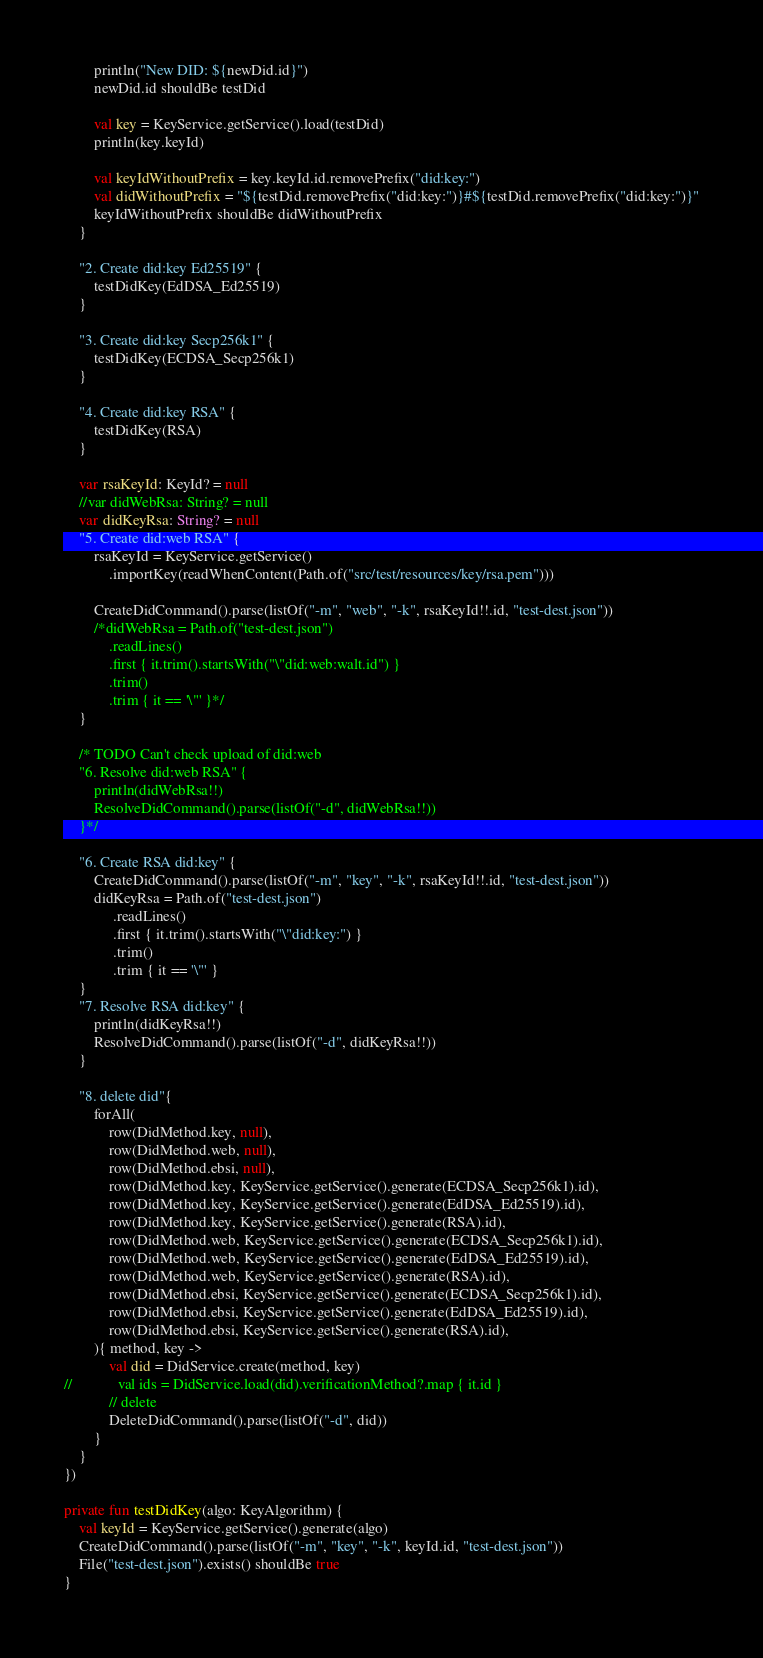Convert code to text. <code><loc_0><loc_0><loc_500><loc_500><_Kotlin_>        println("New DID: ${newDid.id}")
        newDid.id shouldBe testDid

        val key = KeyService.getService().load(testDid)
        println(key.keyId)

        val keyIdWithoutPrefix = key.keyId.id.removePrefix("did:key:")
        val didWithoutPrefix = "${testDid.removePrefix("did:key:")}#${testDid.removePrefix("did:key:")}"
        keyIdWithoutPrefix shouldBe didWithoutPrefix
    }

    "2. Create did:key Ed25519" {
        testDidKey(EdDSA_Ed25519)
    }

    "3. Create did:key Secp256k1" {
        testDidKey(ECDSA_Secp256k1)
    }

    "4. Create did:key RSA" {
        testDidKey(RSA)
    }

    var rsaKeyId: KeyId? = null
    //var didWebRsa: String? = null
    var didKeyRsa: String? = null
    "5. Create did:web RSA" {
        rsaKeyId = KeyService.getService()
            .importKey(readWhenContent(Path.of("src/test/resources/key/rsa.pem")))

        CreateDidCommand().parse(listOf("-m", "web", "-k", rsaKeyId!!.id, "test-dest.json"))
        /*didWebRsa = Path.of("test-dest.json")
            .readLines()
            .first { it.trim().startsWith("\"did:web:walt.id") }
            .trim()
            .trim { it == '\"' }*/
    }

    /* TODO Can't check upload of did:web
    "6. Resolve did:web RSA" {
        println(didWebRsa!!)
        ResolveDidCommand().parse(listOf("-d", didWebRsa!!))
    }*/

    "6. Create RSA did:key" {
        CreateDidCommand().parse(listOf("-m", "key", "-k", rsaKeyId!!.id, "test-dest.json"))
        didKeyRsa = Path.of("test-dest.json")
             .readLines()
             .first { it.trim().startsWith("\"did:key:") }
             .trim()
             .trim { it == '\"' }
    }
    "7. Resolve RSA did:key" {
        println(didKeyRsa!!)
        ResolveDidCommand().parse(listOf("-d", didKeyRsa!!))
    }

    "8. delete did"{
        forAll(
            row(DidMethod.key, null),
            row(DidMethod.web, null),
            row(DidMethod.ebsi, null),
            row(DidMethod.key, KeyService.getService().generate(ECDSA_Secp256k1).id),
            row(DidMethod.key, KeyService.getService().generate(EdDSA_Ed25519).id),
            row(DidMethod.key, KeyService.getService().generate(RSA).id),
            row(DidMethod.web, KeyService.getService().generate(ECDSA_Secp256k1).id),
            row(DidMethod.web, KeyService.getService().generate(EdDSA_Ed25519).id),
            row(DidMethod.web, KeyService.getService().generate(RSA).id),
            row(DidMethod.ebsi, KeyService.getService().generate(ECDSA_Secp256k1).id),
            row(DidMethod.ebsi, KeyService.getService().generate(EdDSA_Ed25519).id),
            row(DidMethod.ebsi, KeyService.getService().generate(RSA).id),
        ){ method, key ->
            val did = DidService.create(method, key)
//            val ids = DidService.load(did).verificationMethod?.map { it.id }
            // delete
            DeleteDidCommand().parse(listOf("-d", did))
        }
    }
})

private fun testDidKey(algo: KeyAlgorithm) {
    val keyId = KeyService.getService().generate(algo)
    CreateDidCommand().parse(listOf("-m", "key", "-k", keyId.id, "test-dest.json"))
    File("test-dest.json").exists() shouldBe true
}
</code> 